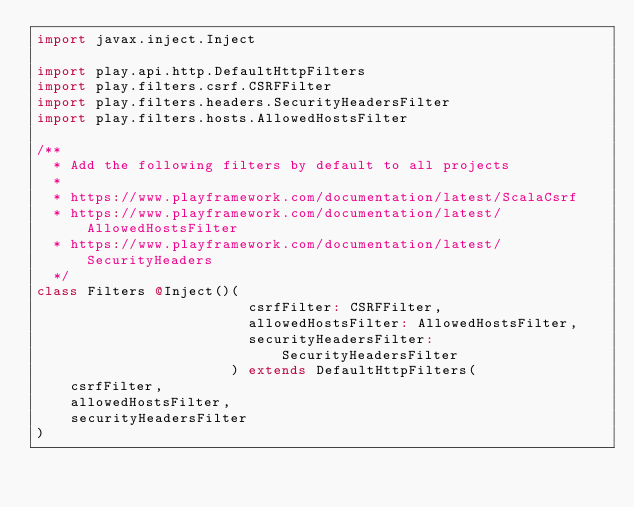<code> <loc_0><loc_0><loc_500><loc_500><_Scala_>import javax.inject.Inject

import play.api.http.DefaultHttpFilters
import play.filters.csrf.CSRFFilter
import play.filters.headers.SecurityHeadersFilter
import play.filters.hosts.AllowedHostsFilter

/**
  * Add the following filters by default to all projects
  *
  * https://www.playframework.com/documentation/latest/ScalaCsrf
  * https://www.playframework.com/documentation/latest/AllowedHostsFilter
  * https://www.playframework.com/documentation/latest/SecurityHeaders
  */
class Filters @Inject()(
                         csrfFilter: CSRFFilter,
                         allowedHostsFilter: AllowedHostsFilter,
                         securityHeadersFilter: SecurityHeadersFilter
                       ) extends DefaultHttpFilters(
    csrfFilter,
    allowedHostsFilter,
    securityHeadersFilter
)
</code> 